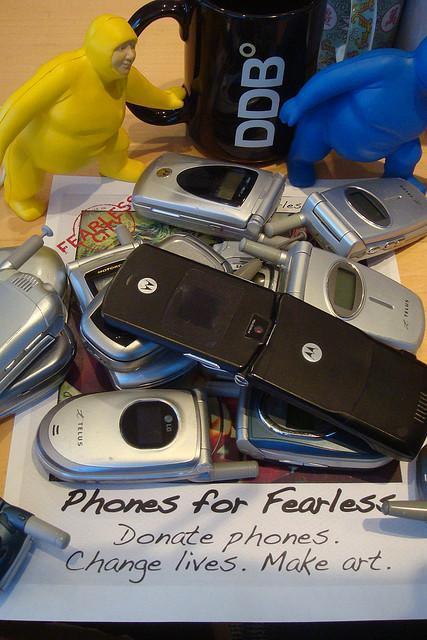How many cell phones are in the photo?
Give a very brief answer. 10. 